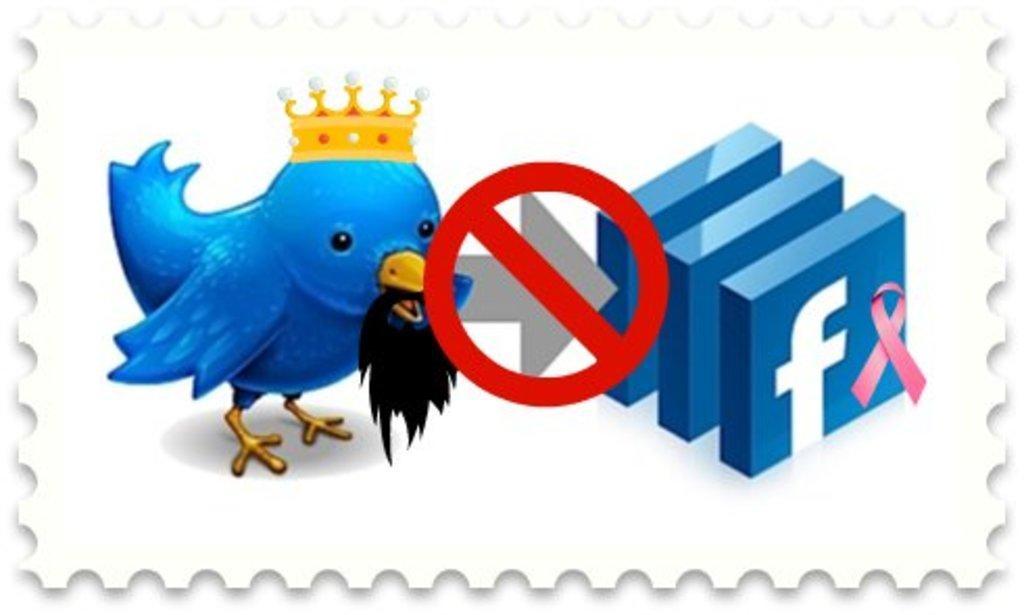Can you describe this image briefly? This is the picture of a bird which has a crown and to the side there are some symbols and signs. 